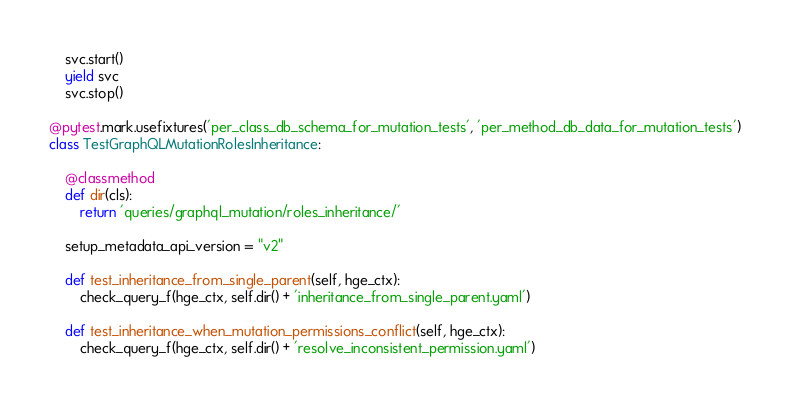Convert code to text. <code><loc_0><loc_0><loc_500><loc_500><_Python_>    svc.start()
    yield svc
    svc.stop()

@pytest.mark.usefixtures('per_class_db_schema_for_mutation_tests', 'per_method_db_data_for_mutation_tests')
class TestGraphQLMutationRolesInheritance:

    @classmethod
    def dir(cls):
        return 'queries/graphql_mutation/roles_inheritance/'

    setup_metadata_api_version = "v2"

    def test_inheritance_from_single_parent(self, hge_ctx):
        check_query_f(hge_ctx, self.dir() + 'inheritance_from_single_parent.yaml')

    def test_inheritance_when_mutation_permissions_conflict(self, hge_ctx):
        check_query_f(hge_ctx, self.dir() + 'resolve_inconsistent_permission.yaml')
</code> 